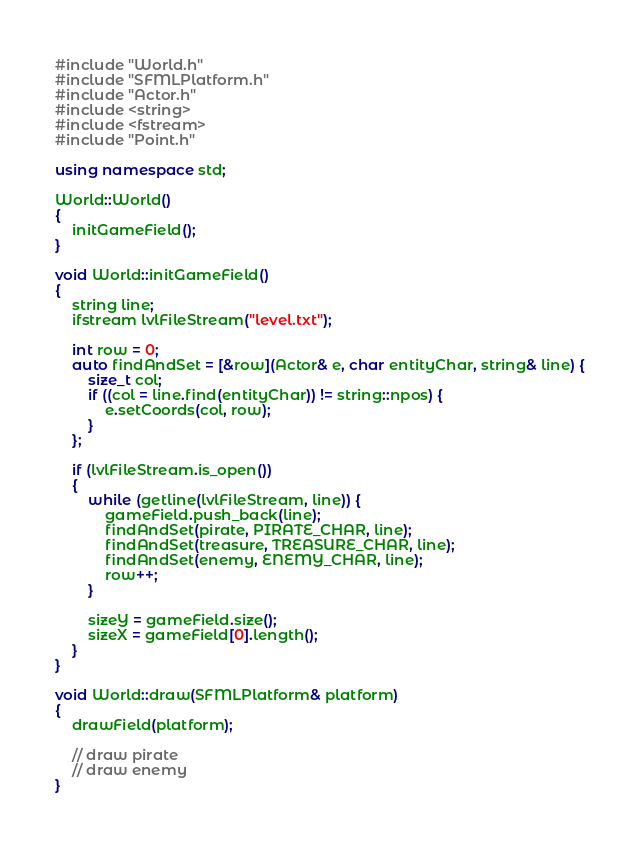<code> <loc_0><loc_0><loc_500><loc_500><_C++_>#include "World.h"
#include "SFMLPlatform.h"
#include "Actor.h"
#include <string>
#include <fstream>
#include "Point.h"

using namespace std;

World::World()
{
	initGameField();
}

void World::initGameField()
{
	string line;
	ifstream lvlFileStream("level.txt");

	int row = 0;
	auto findAndSet = [&row](Actor& e, char entityChar, string& line) {
		size_t col;
		if ((col = line.find(entityChar)) != string::npos) {
			e.setCoords(col, row);
		}
	};

	if (lvlFileStream.is_open())
	{
		while (getline(lvlFileStream, line)) {
			gameField.push_back(line);
			findAndSet(pirate, PIRATE_CHAR, line);
			findAndSet(treasure, TREASURE_CHAR, line);
			findAndSet(enemy, ENEMY_CHAR, line);
			row++;
		}

		sizeY = gameField.size();
		sizeX = gameField[0].length();
	}
}

void World::draw(SFMLPlatform& platform)
{
	drawField(platform);

	// draw pirate
	// draw enemy
}
</code> 